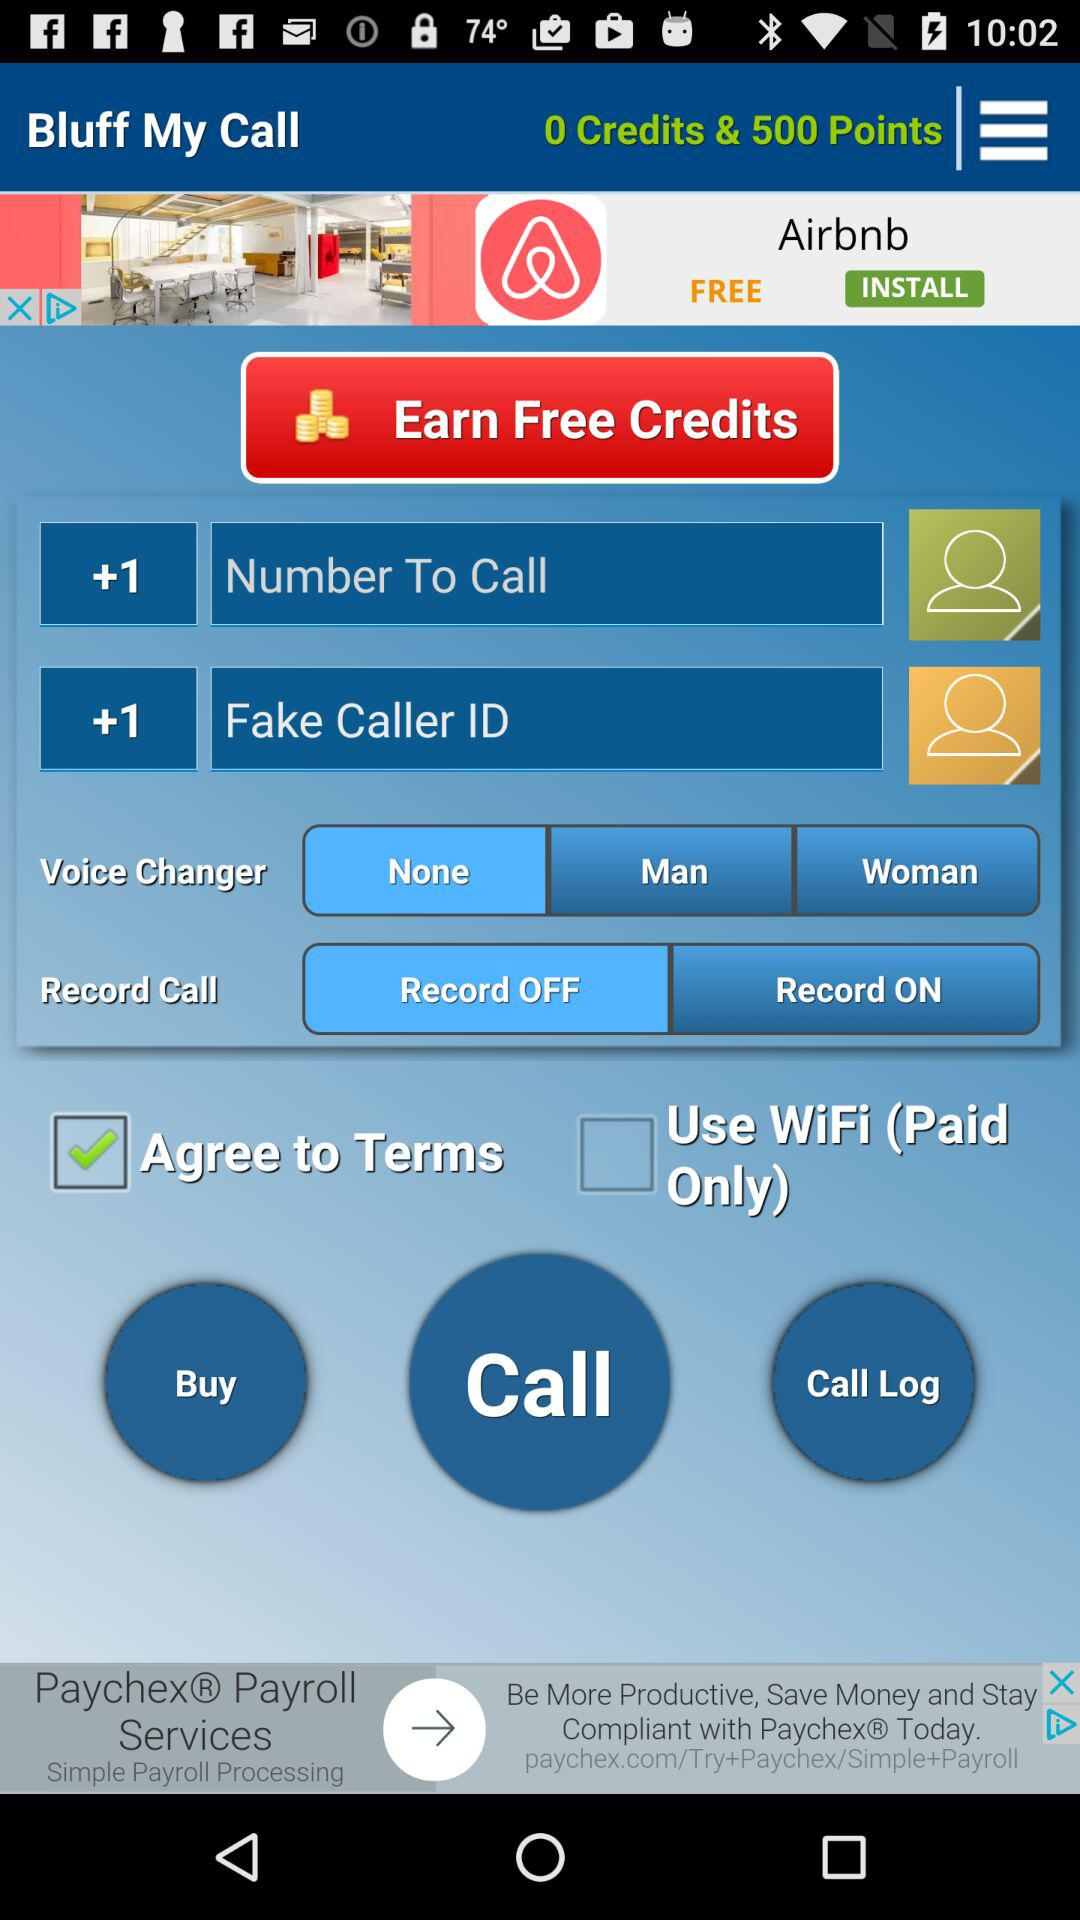Is WiFi free or paid?
Answer the question using a single word or phrase. Wifi is paid. 